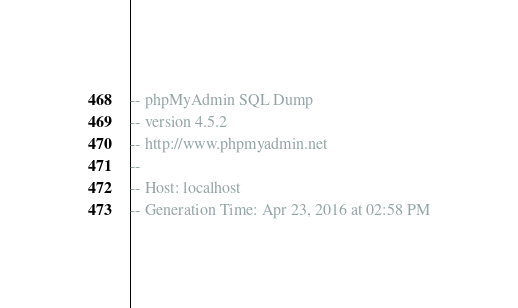Convert code to text. <code><loc_0><loc_0><loc_500><loc_500><_SQL_>-- phpMyAdmin SQL Dump
-- version 4.5.2
-- http://www.phpmyadmin.net
--
-- Host: localhost
-- Generation Time: Apr 23, 2016 at 02:58 PM</code> 